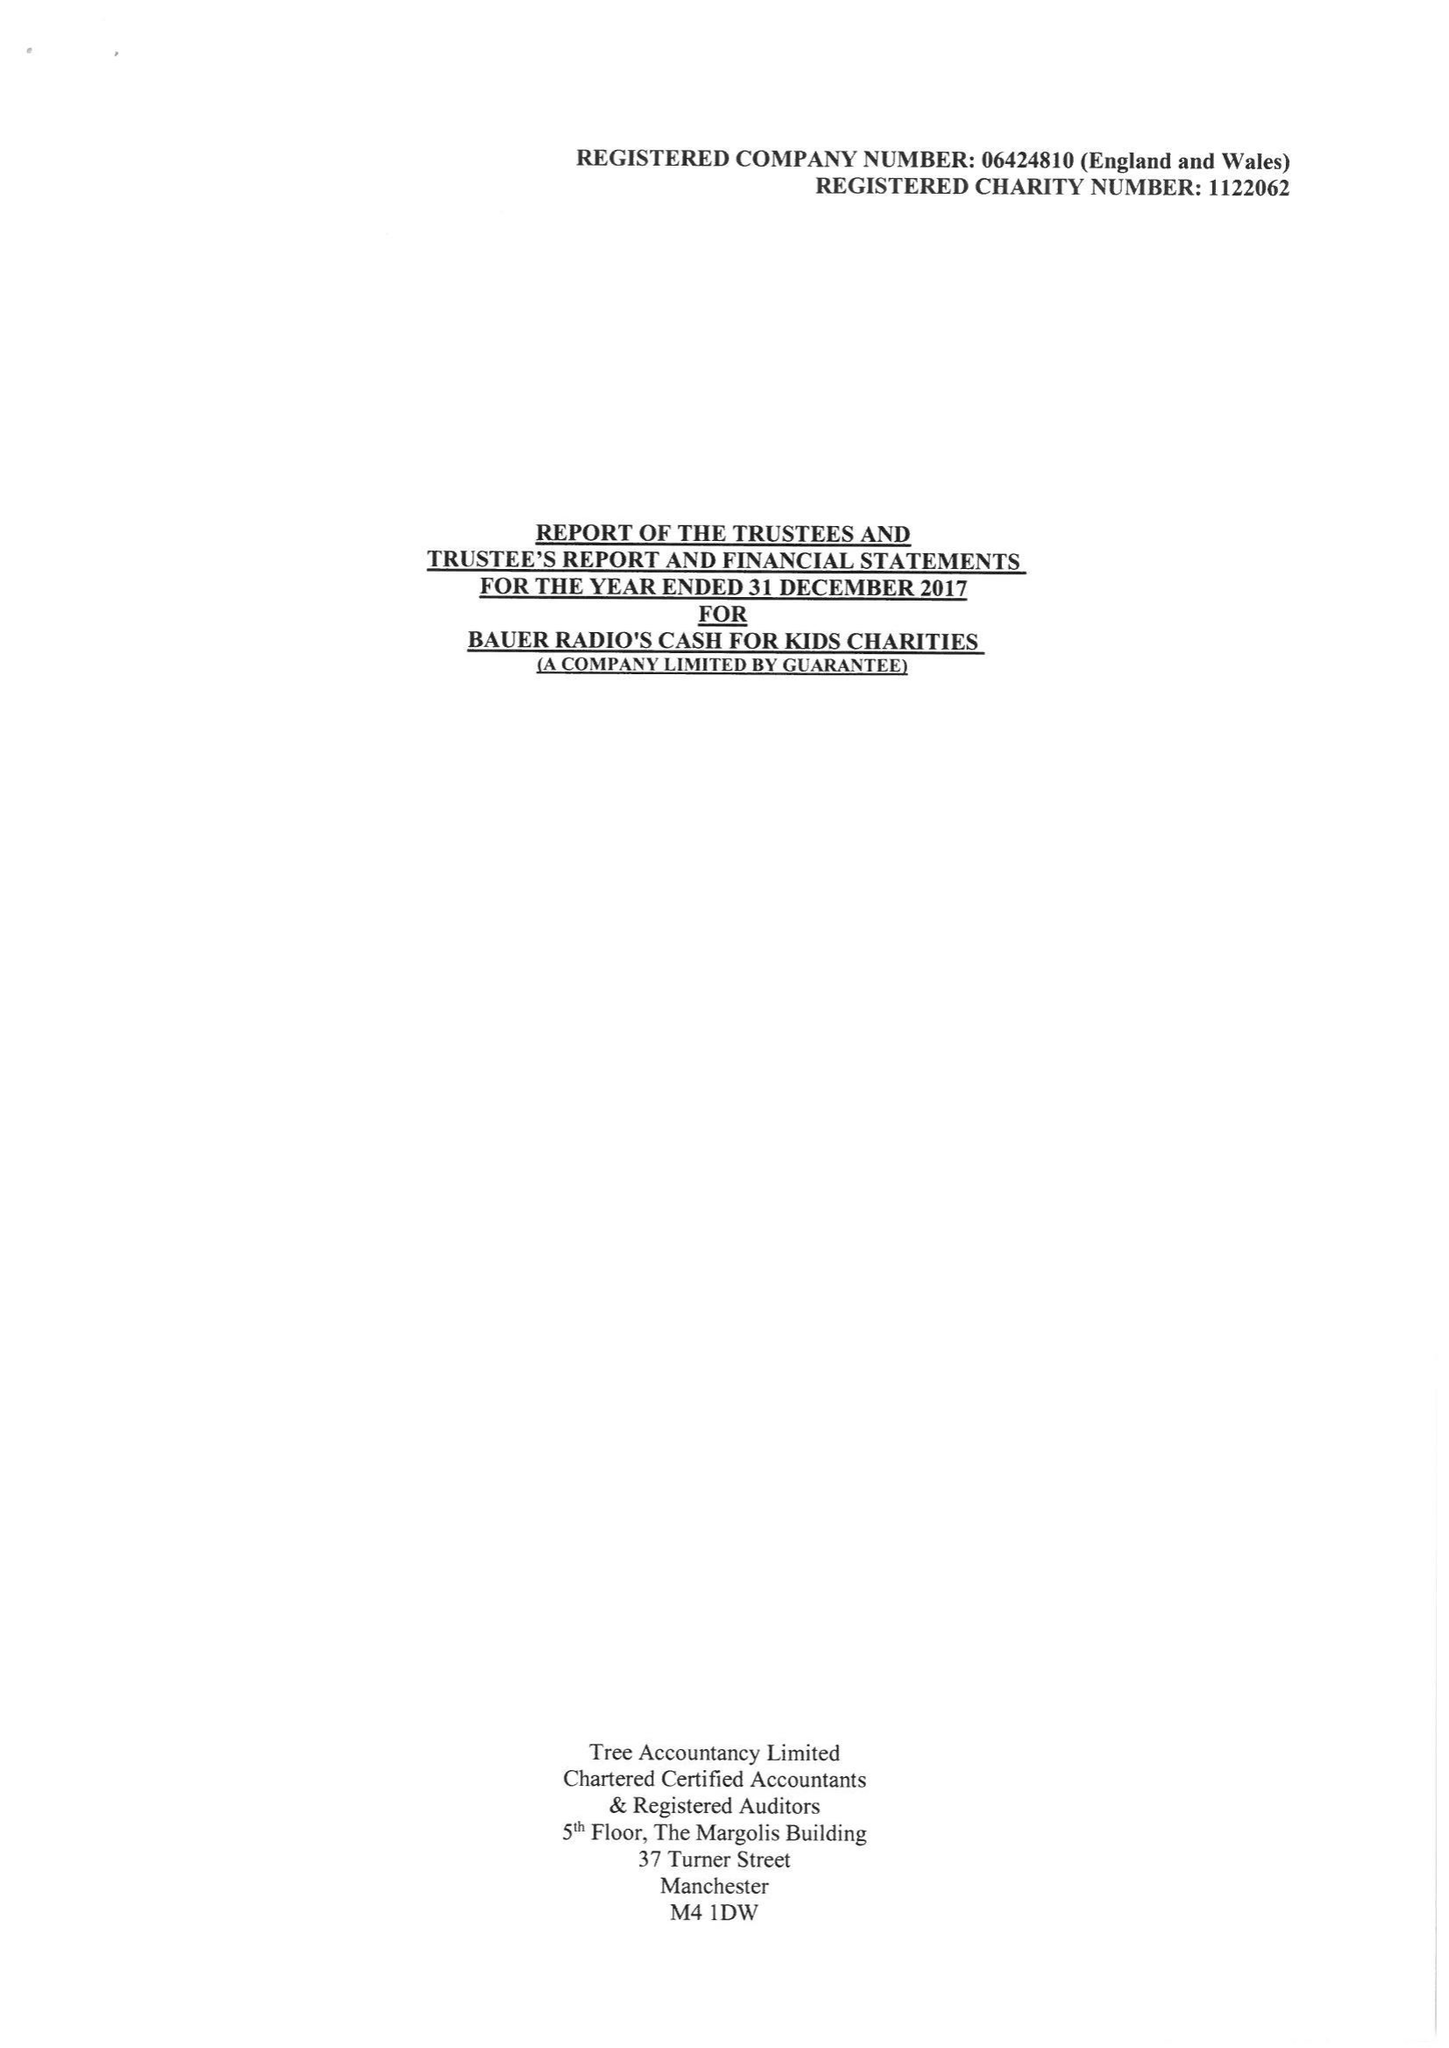What is the value for the address__street_line?
Answer the question using a single word or phrase. None 